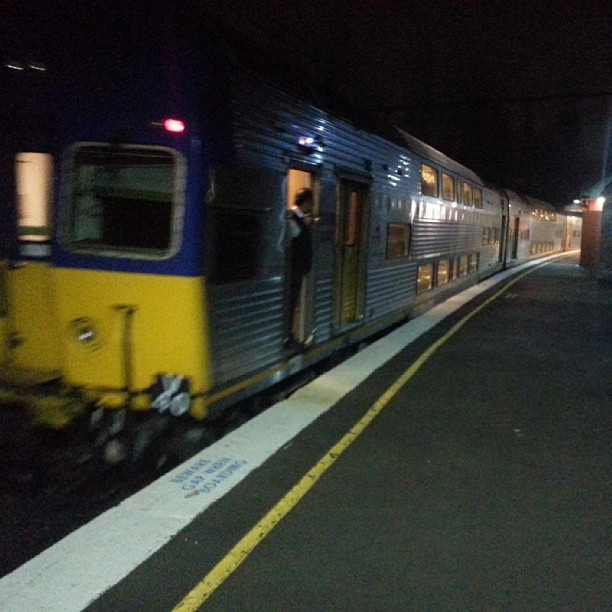Describe the objects in this image and their specific colors. I can see train in black, gray, and olive tones and people in black, gray, and purple tones in this image. 